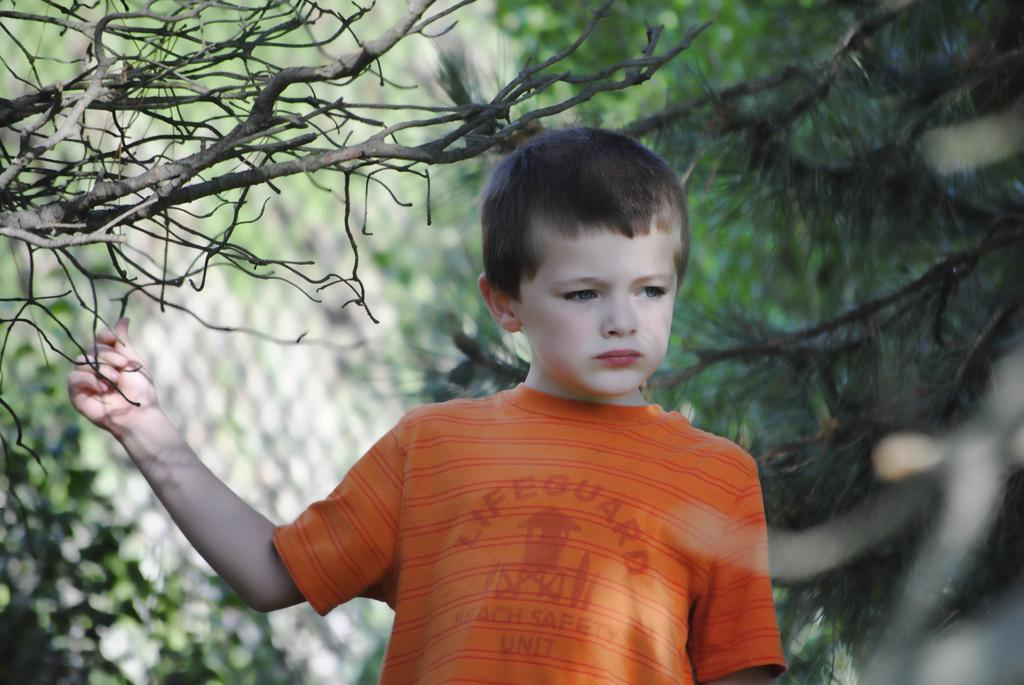Who is the main subject in the center of the picture? There is a boy in the center of the picture. What is the boy wearing? The boy is wearing an orange t-shirt. What can be seen on the left side of the image? There are branches of a tree on the left side of the image. How would you describe the background of the image? The background of the image is blurred. What type of vegetation is visible in the background? There is greenery in the background of the image. Can you tell me how many yaks are present in the image? There are no yaks present in the image. What type of arch can be seen in the background of the image? There is no arch present in the image. 